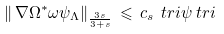Convert formula to latex. <formula><loc_0><loc_0><loc_500><loc_500>\left \| \, \nabla \Omega ^ { * } \omega \psi _ { \Lambda } \right \| _ { \frac { 3 s } { 3 + s } } & \, \leqslant \, c _ { s } \, \ t r i \psi \ t r i</formula> 